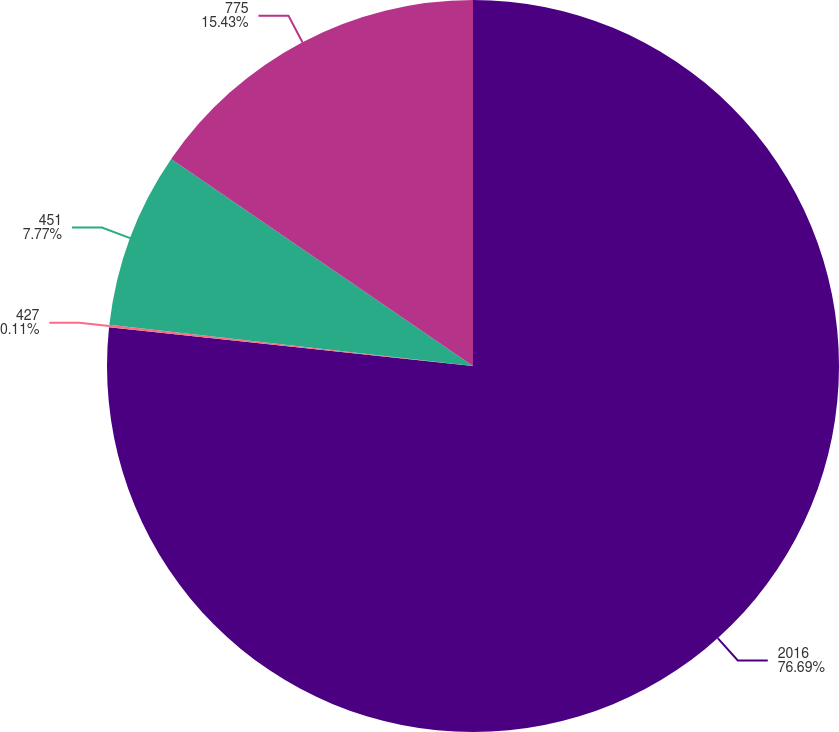Convert chart. <chart><loc_0><loc_0><loc_500><loc_500><pie_chart><fcel>2016<fcel>427<fcel>451<fcel>775<nl><fcel>76.68%<fcel>0.11%<fcel>7.77%<fcel>15.43%<nl></chart> 